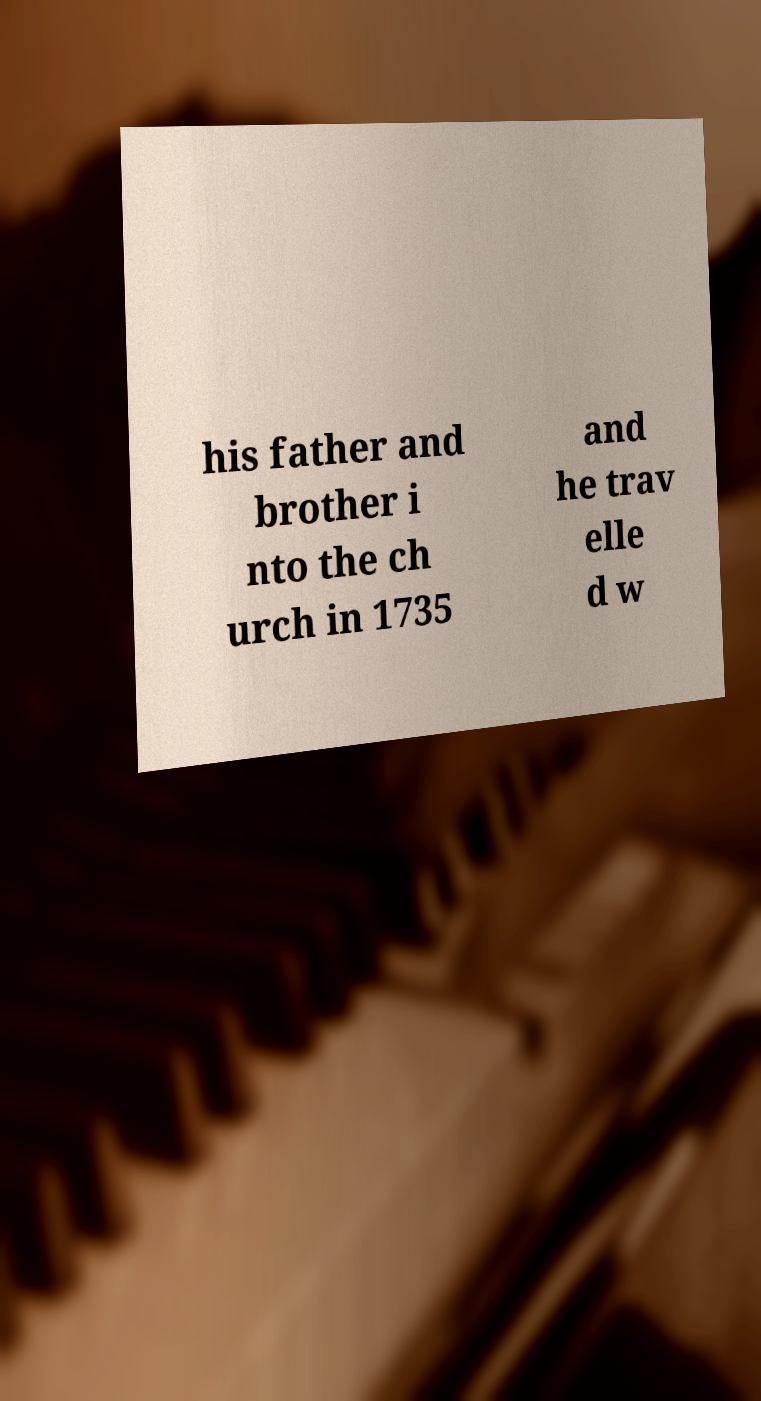There's text embedded in this image that I need extracted. Can you transcribe it verbatim? his father and brother i nto the ch urch in 1735 and he trav elle d w 